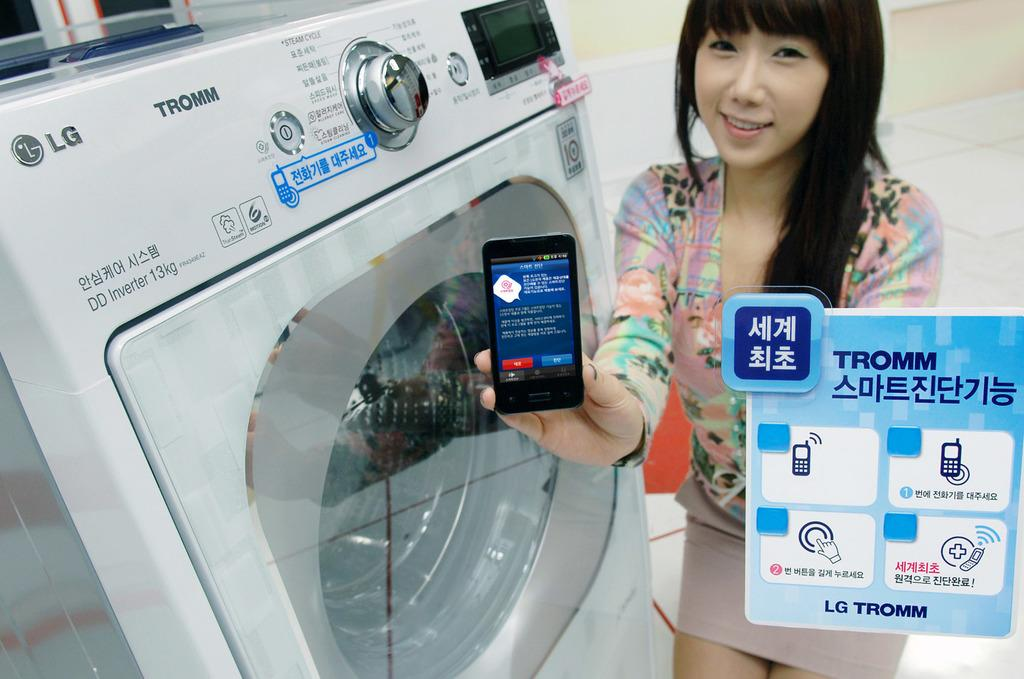<image>
Present a compact description of the photo's key features. A girl holding an electronic device with a corner shot in a foreign language saying LG TROMM. 